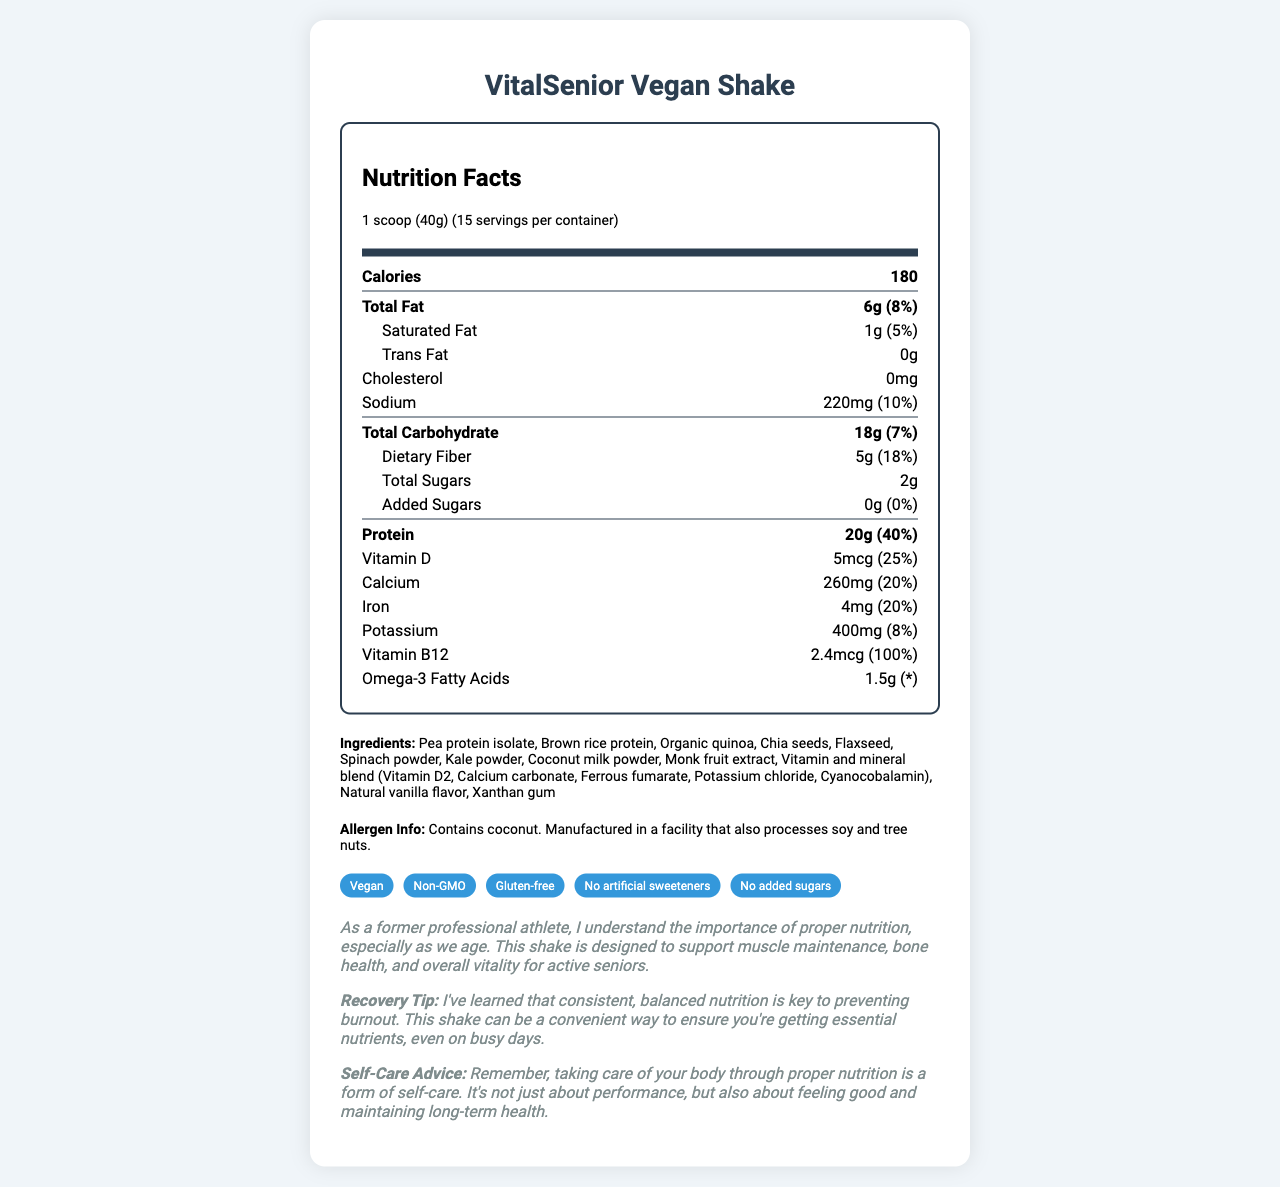who is the product designed for? The label states that "This shake is designed to support muscle maintenance, bone health, and overall vitality for active seniors."
Answer: active seniors what is the serving size of VitalSenior Vegan Shake? The serving size is specified as "1 scoop (40g)" on the label.
Answer: 1 scoop (40g) how many calories are in one serving of VitalSenior Vegan Shake? The label states that one serving contains 180 calories.
Answer: 180 what is the amount of dietary fiber in one serving? The nutritional information clearly shows that there are 5g of dietary fiber per serving.
Answer: 5g does the shake contain any added sugars? The label indicates 0g of added sugars.
Answer: No what type of protein is used in VitalSenior Vegan Shake? The ingredients list includes pea protein isolate and brown rice protein.
Answer: pea protein isolate, brown rice protein which vitamins and minerals are included in the vitamin and mineral blend? The ingredients list specifies these components as part of the vitamin and mineral blend.
Answer: Vitamin D2, Calcium carbonate, Ferrous fumarate, Potassium chloride, Cyanocobalamin is the product free from gluten? The label includes a lifestyle claim that the product is gluten-free.
Answer: Yes which ingredient may cause an allergic reaction? The allergen info specifies that the product contains coconut.
Answer: coconut how many servings are there in a container? The label states that there are 15 servings per container.
Answer: 15 how much protein does one serving of VitalSenior Vegan Shake provide? The nutritional information shows that one serving contains 20g of protein.
Answer: 20g what is the daily value percentage of Vitamin B12 in one serving? The label states that one serving provides 100% of the daily value of Vitamin B12.
Answer: 100% does the product contain soy? The allergen info specifies that while the product does not contain soy, it is manufactured in a facility that processes soy.
Answer: No, but it's manufactured in a facility that also processes soy which of the following claims is not made about the product? A. Vegan B. Non-GMO C. Contains artificial sweeteners The label claims the product is Vegan, Non-GMO, and does not contain artificial sweeteners.
Answer: C which nutrient helps support bone health? A. Protein B. Carbohydrates C. Vitamin D Vitamin D is known for supporting bone health, which is detailed in the additional athlete notes.
Answer: C what is the main idea of the document? The entire document revolves around the nutritional content, ingredients, allergen info, and lifestyle claims related to VitalSenior Vegan Shake, along with additional notes on its benefits for active seniors.
Answer: The document provides nutritional information about a vegan, nutrient-dense meal replacement shake tailored for active seniors, including its ingredients, lifestyle claims, and benefits. how can consistent, balanced nutrition help active seniors? The athlete's notes and recovery tip emphasize the importance of balanced nutrition in maintaining health and vitality for active seniors.
Answer: It can prevent burnout and help maintain muscle, bone health, and overall vitality. what flavor is the VitalSenior Vegan Shake? The ingredients list specifies that the shake is flavored with natural vanilla.
Answer: natural vanilla flavor what are the three primary protein sources listed in the ingredients? A. Pea protein isolate, Brown rice protein, Organic quinoa B. Chia seeds, Flaxseed, Spinach powder C. Coconut milk powder, Monk fruit extract, Xanthan gum Pea protein isolate, Brown rice protein, and Organic quinoa are the primary protein sources mentioned.
Answer: A how does the product support senior athletes? The athlete's notes explain that the shake is designed to support muscle maintenance, bone health, and overall vitality, which are crucial for senior athletes.
Answer: It provides essential nutrients for muscle maintenance, bone health, and overall vitality. is there any information on how to prepare the shake? There is no preparation information provided in the document.
Answer: Cannot be determined 